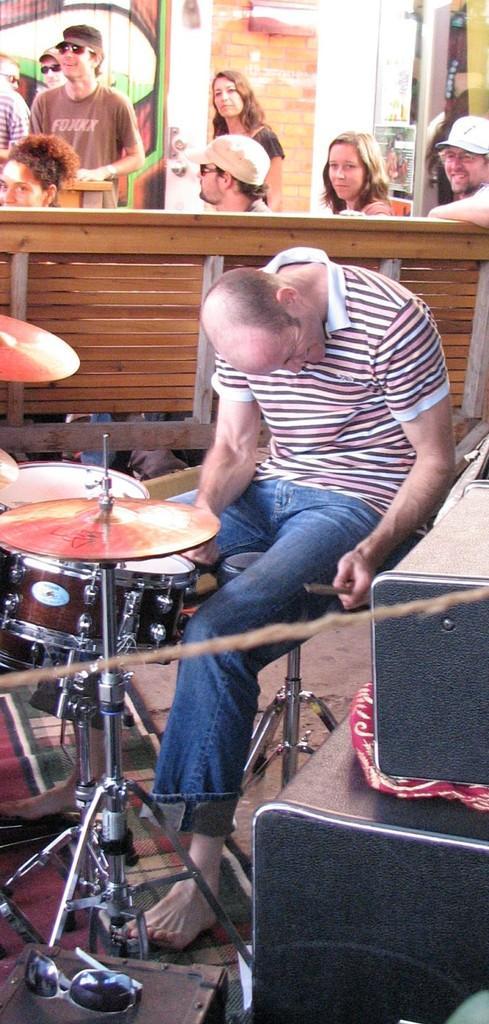How would you summarize this image in a sentence or two? In front of the picture, we see a man is playing the drums. On the right side, we see the black color objects. Beside that, we see a stool on which the goggles are placed. Behind him, we see a bench on which the people are sitting. Beside them, we see the people are standing. In the background, we see a wall. On the left side, we see a wall graffiti. 